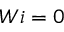Convert formula to latex. <formula><loc_0><loc_0><loc_500><loc_500>W i = 0</formula> 